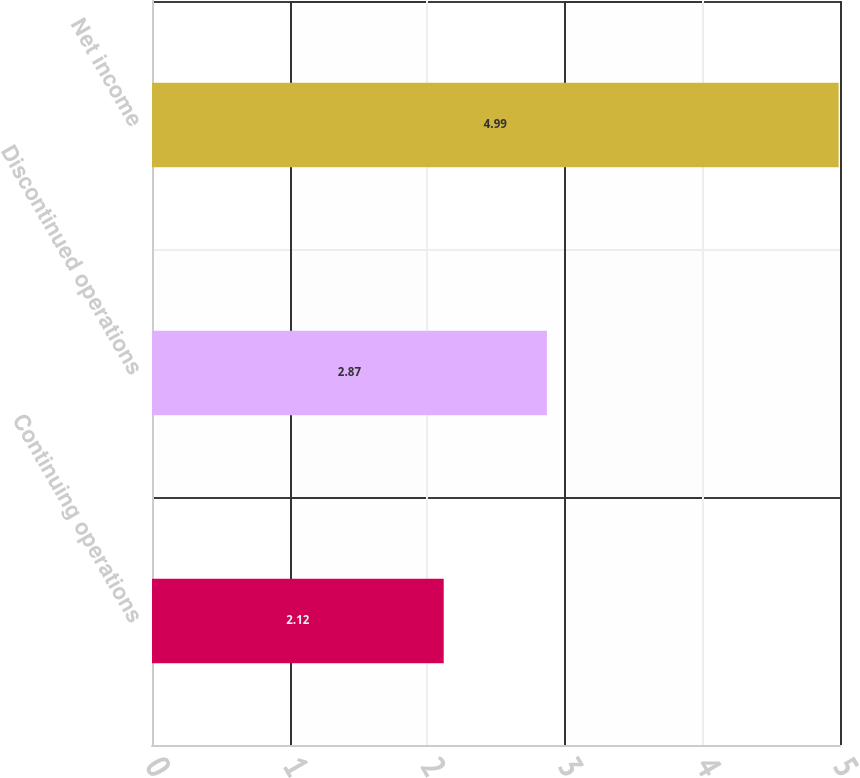Convert chart to OTSL. <chart><loc_0><loc_0><loc_500><loc_500><bar_chart><fcel>Continuing operations<fcel>Discontinued operations<fcel>Net income<nl><fcel>2.12<fcel>2.87<fcel>4.99<nl></chart> 